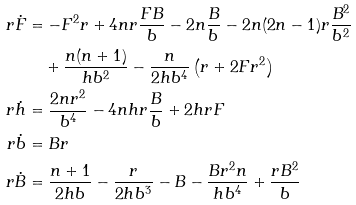<formula> <loc_0><loc_0><loc_500><loc_500>r \dot { F } & = - F ^ { 2 } r + 4 n r \frac { F B } { b } - 2 n \frac { B } { b } - 2 n ( 2 n - 1 ) r \frac { B ^ { 2 } } { b ^ { 2 } } \\ & \quad + \frac { n ( n + 1 ) } { h b ^ { 2 } } - \frac { n } { 2 h b ^ { 4 } } \left ( r + 2 F r ^ { 2 } \right ) \\ r \dot { h } & = \frac { 2 n r ^ { 2 } } { b ^ { 4 } } - 4 n h r \frac { B } { b } + 2 h r F \\ r \dot { b } & = B r \\ r \dot { B } & = \frac { n + 1 } { 2 h b } - \frac { r } { 2 h b ^ { 3 } } - B - \frac { B r ^ { 2 } n } { h b ^ { 4 } } + \frac { r B ^ { 2 } } { b }</formula> 